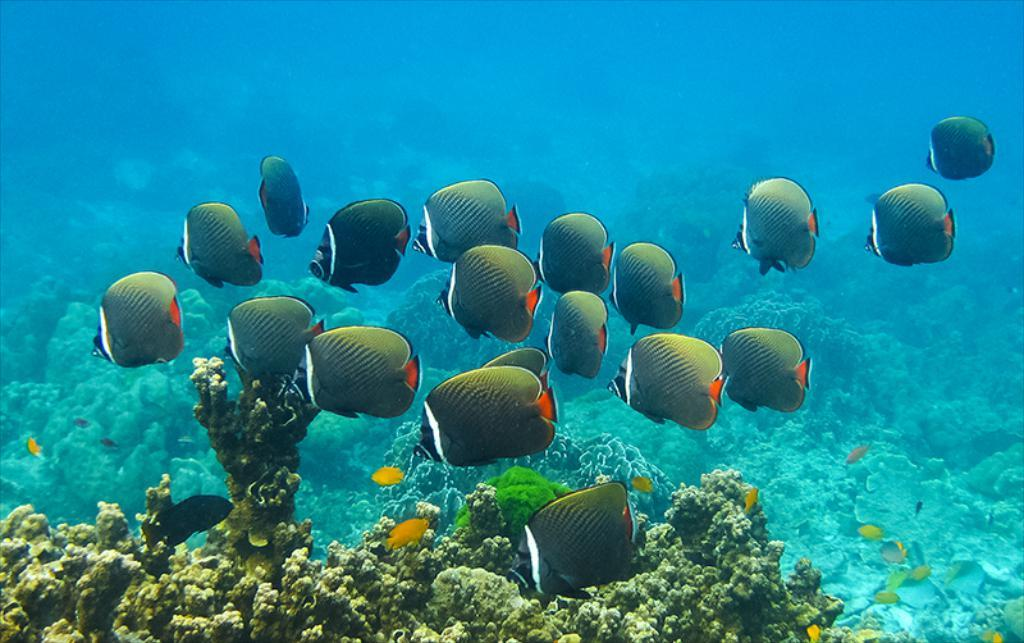What type of environment is shown in the image? The image depicts an underwater scene. What can be found in this underwater environment? There are corals and fishes in the image. How many babies are swimming with the fishes in the image? There are no babies present in the image; it depicts an underwater scene with corals and fishes. 